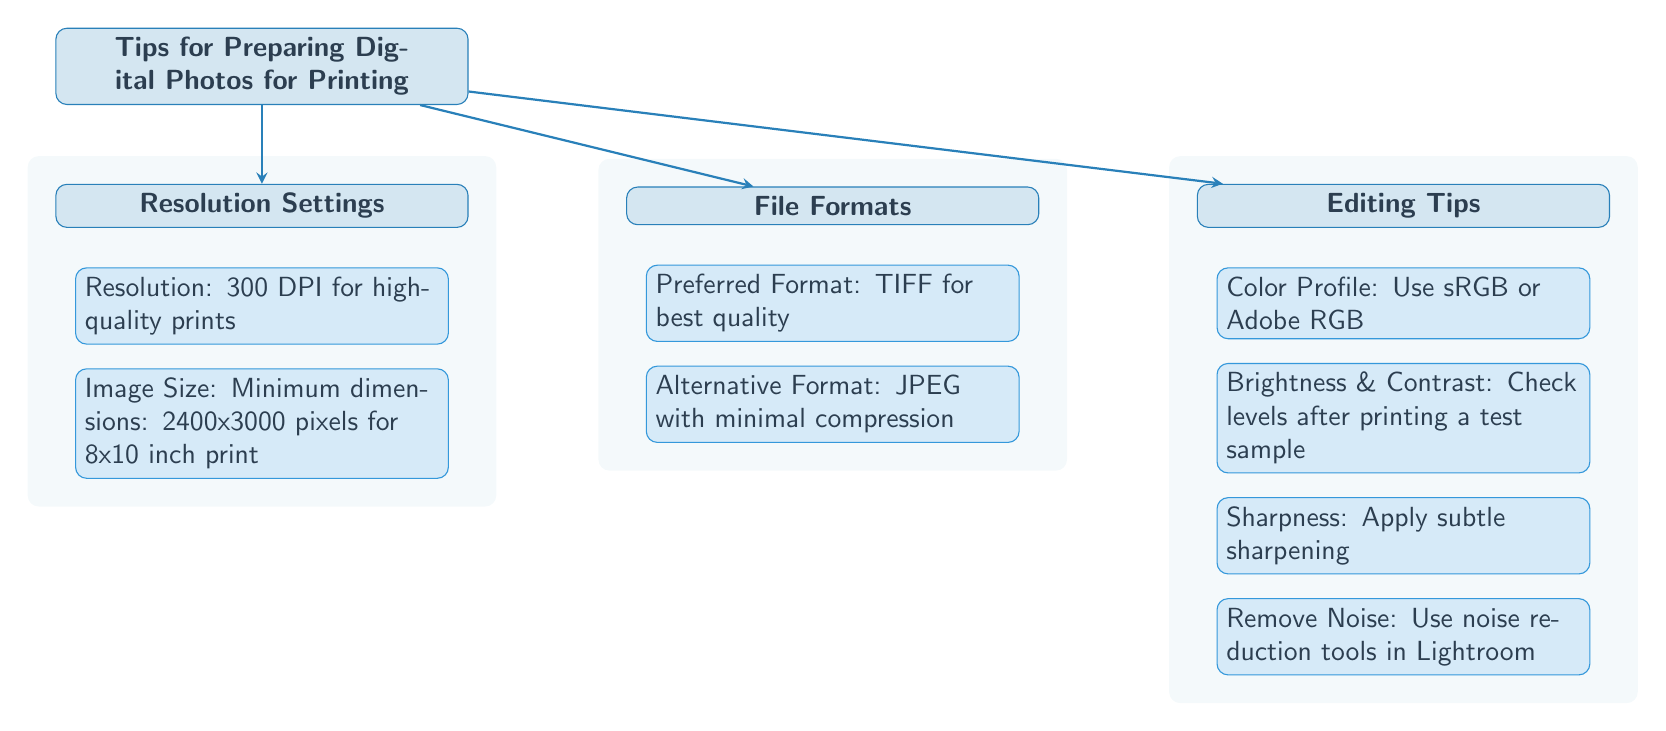What is the recommended resolution for high-quality prints? The diagram indicates that the resolution should be 300 DPI for high-quality prints, which is directly mentioned in the 'Resolution Settings' section.
Answer: 300 DPI What are the minimum dimensions for an 8x10 inch print? The diagram specifies that the minimum dimensions for an 8x10 inch print should be 2400x3000 pixels, as found in the 'Resolution Settings' section.
Answer: 2400x3000 pixels What file format is preferred for best quality? According to the 'File Formats' section in the diagram, the preferred format for printing photos is TIFF, which is explicitly listed there.
Answer: TIFF How many editing tips are provided in the diagram? The 'Editing Tips' section contains four distinct tips, as listed in the sub-nodes beneath the 'Editing Tips' main node.
Answer: 4 What is the importance of checking brightness and contrast? The diagram emphasizes that checking brightness and contrast is crucial after printing a test sample, as mentioned in the 'Editing Tips' section.
Answer: Check levels after printing What color profile is suggested for digital photos? The diagram suggests using sRGB or Adobe RGB color profile, as stated directly in the 'Editing Tips' section.
Answer: sRGB or Adobe RGB Which file format is listed as an alternative with minimal compression? The diagram indicates that JPEG is an alternative format listed under the 'File Formats' section and specifically mentions it should have minimal compression.
Answer: JPEG What should be done to sharpen the image? The diagram advises applying subtle sharpening as one of the editing tips listed under the 'Editing Tips' section.
Answer: Apply subtle sharpening What is the purpose of removing noise according to the diagram? The diagram indicates that noise should be removed using noise reduction tools in Lightroom, as specified in the 'Editing Tips' section, suggesting it is to enhance image quality.
Answer: Use noise reduction tools in Lightroom 